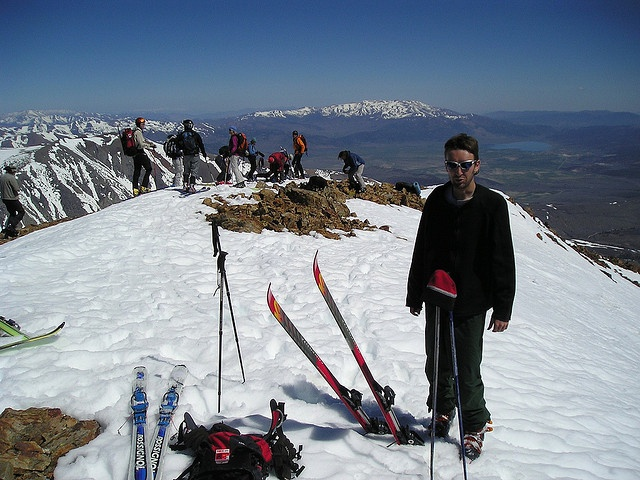Describe the objects in this image and their specific colors. I can see people in navy, black, gray, lightgray, and maroon tones, backpack in navy, black, gray, maroon, and brown tones, skis in navy, black, lightgray, gray, and maroon tones, skis in navy, darkgray, black, gray, and lightgray tones, and people in navy, black, gray, darkgray, and maroon tones in this image. 